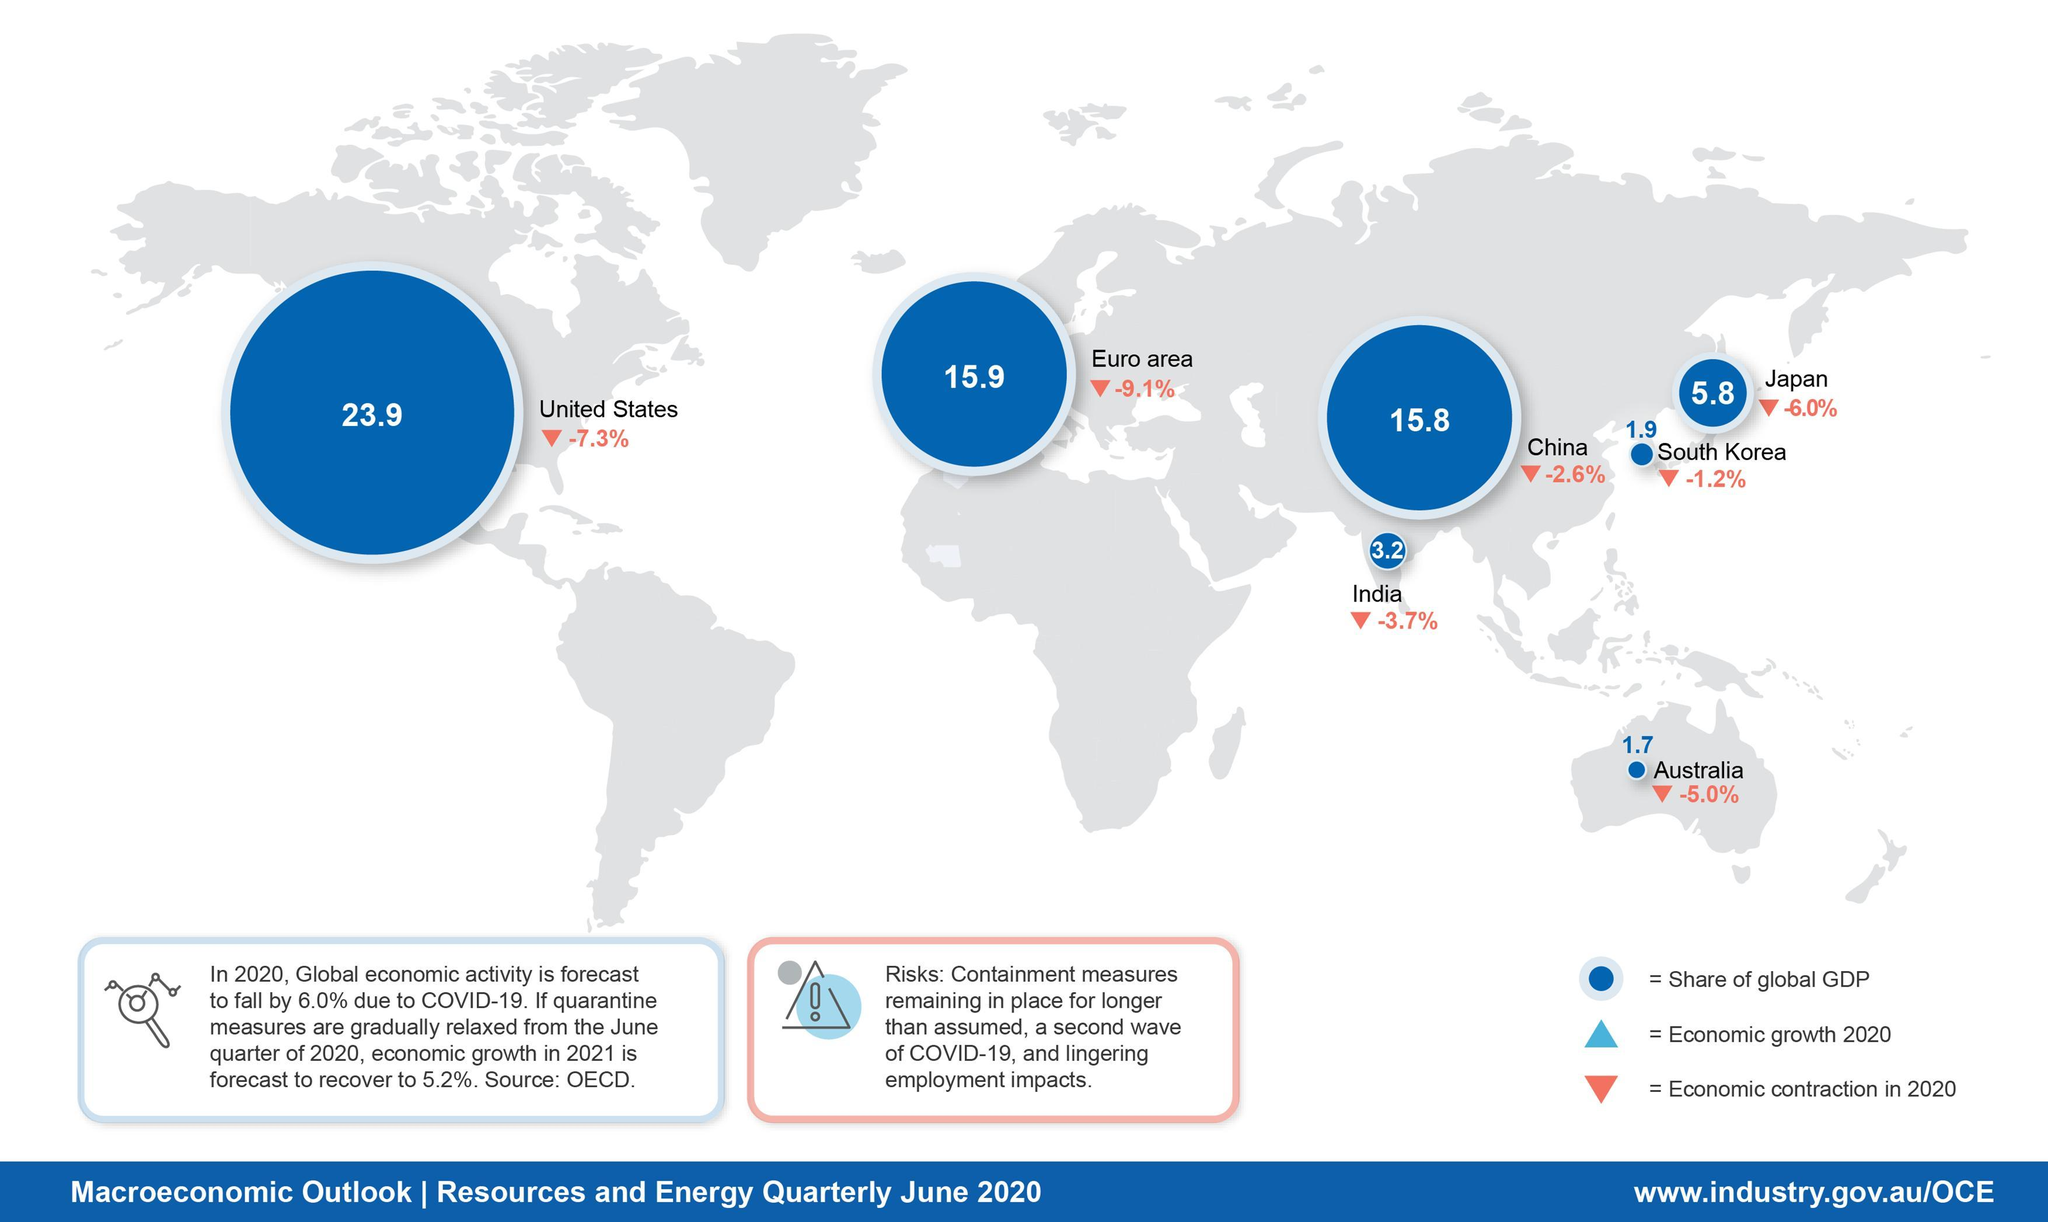What is economic contraction in china in quarter June 2020?
Answer the question with a short phrase. -2.6% What is the U.S.'s share of global GDP in quarter June 2020? 23.9 What is the China's share of global GDP in quarter June 2020? 15.8 What is the India's share of global GDP in quarter June 2020? 3.2 What is economic contraction in Australia in quarter June 2020? -5.0% 